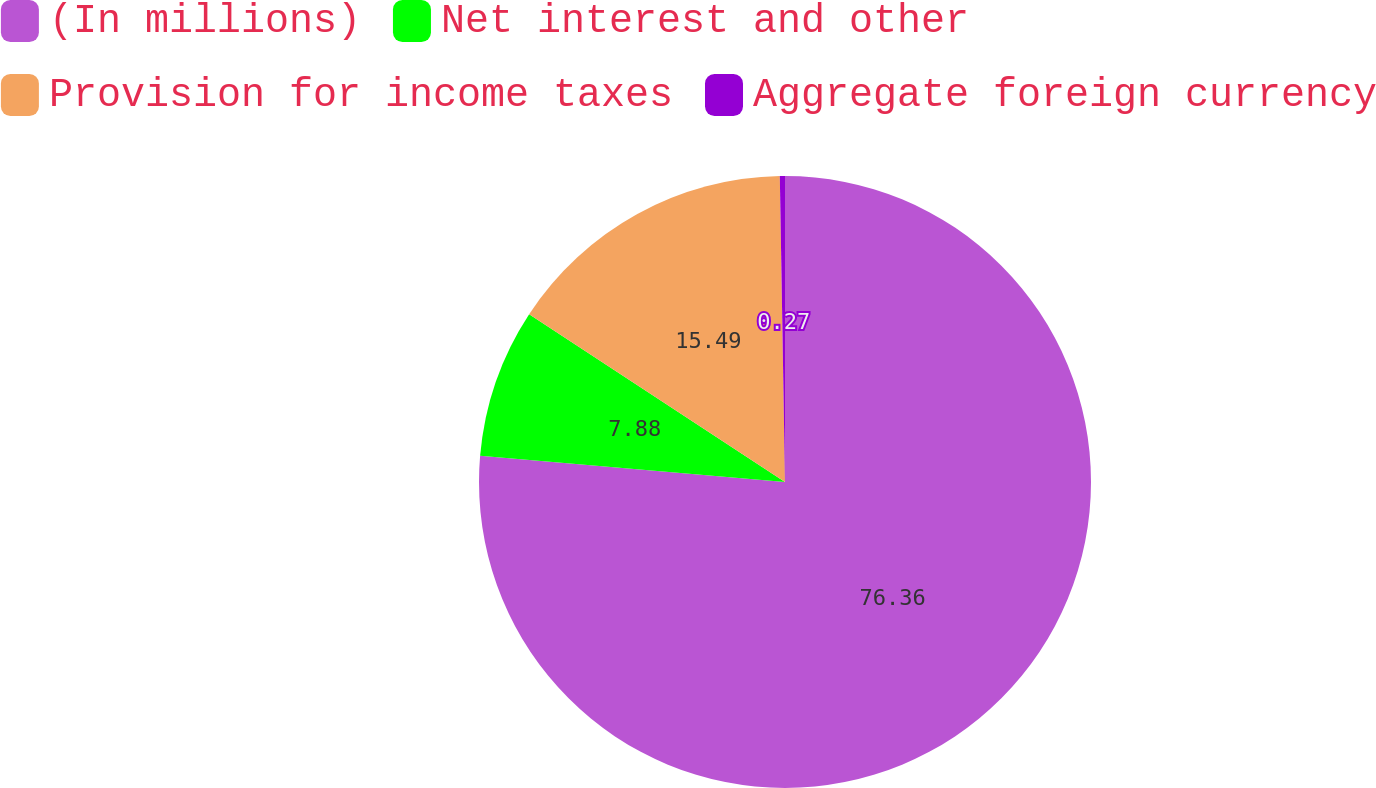<chart> <loc_0><loc_0><loc_500><loc_500><pie_chart><fcel>(In millions)<fcel>Net interest and other<fcel>Provision for income taxes<fcel>Aggregate foreign currency<nl><fcel>76.37%<fcel>7.88%<fcel>15.49%<fcel>0.27%<nl></chart> 